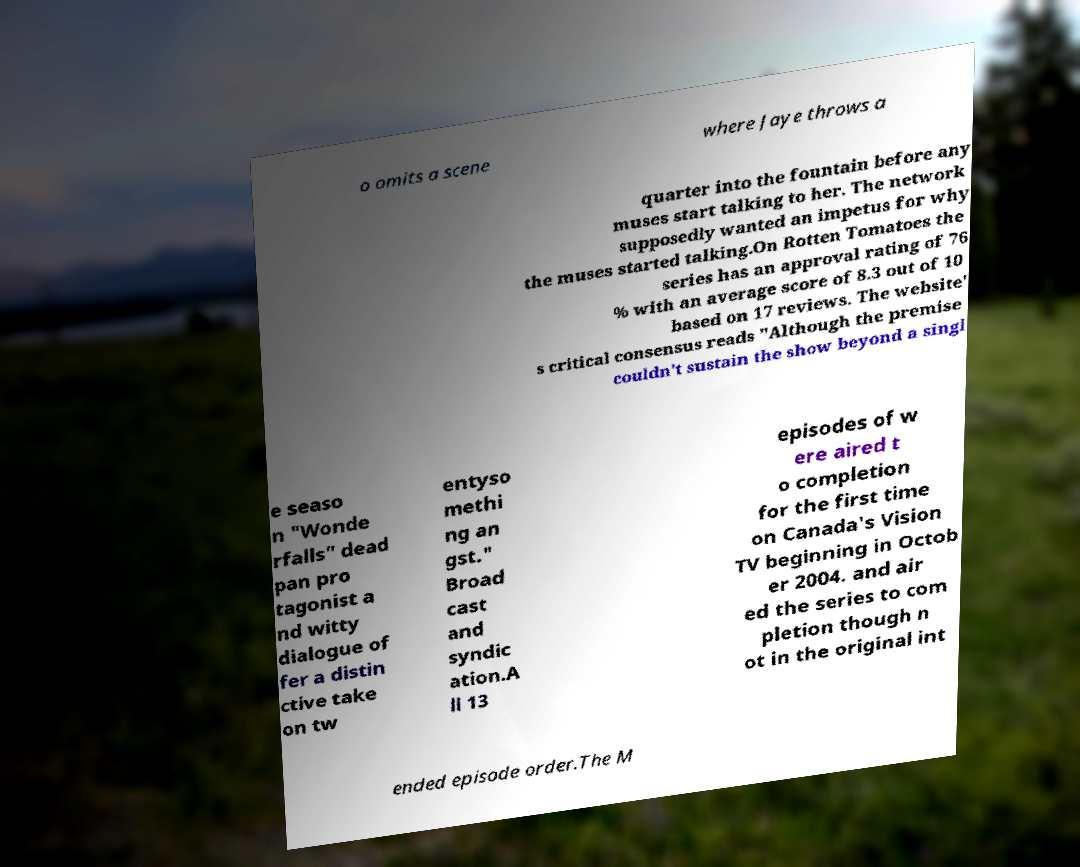There's text embedded in this image that I need extracted. Can you transcribe it verbatim? o omits a scene where Jaye throws a quarter into the fountain before any muses start talking to her. The network supposedly wanted an impetus for why the muses started talking.On Rotten Tomatoes the series has an approval rating of 76 % with an average score of 8.3 out of 10 based on 17 reviews. The website' s critical consensus reads "Although the premise couldn't sustain the show beyond a singl e seaso n "Wonde rfalls" dead pan pro tagonist a nd witty dialogue of fer a distin ctive take on tw entyso methi ng an gst." Broad cast and syndic ation.A ll 13 episodes of w ere aired t o completion for the first time on Canada's Vision TV beginning in Octob er 2004. and air ed the series to com pletion though n ot in the original int ended episode order.The M 